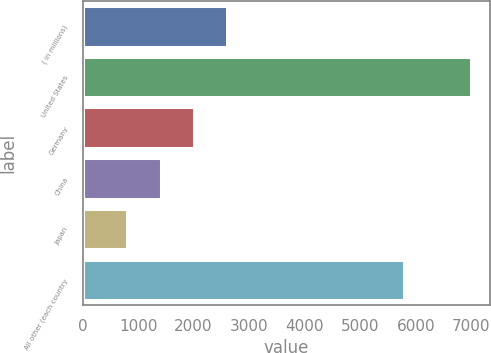Convert chart. <chart><loc_0><loc_0><loc_500><loc_500><bar_chart><fcel>( in millions)<fcel>United States<fcel>Germany<fcel>China<fcel>Japan<fcel>All other (each country<nl><fcel>2602.92<fcel>6983.98<fcel>2005.08<fcel>1407.24<fcel>809.4<fcel>5788.3<nl></chart> 